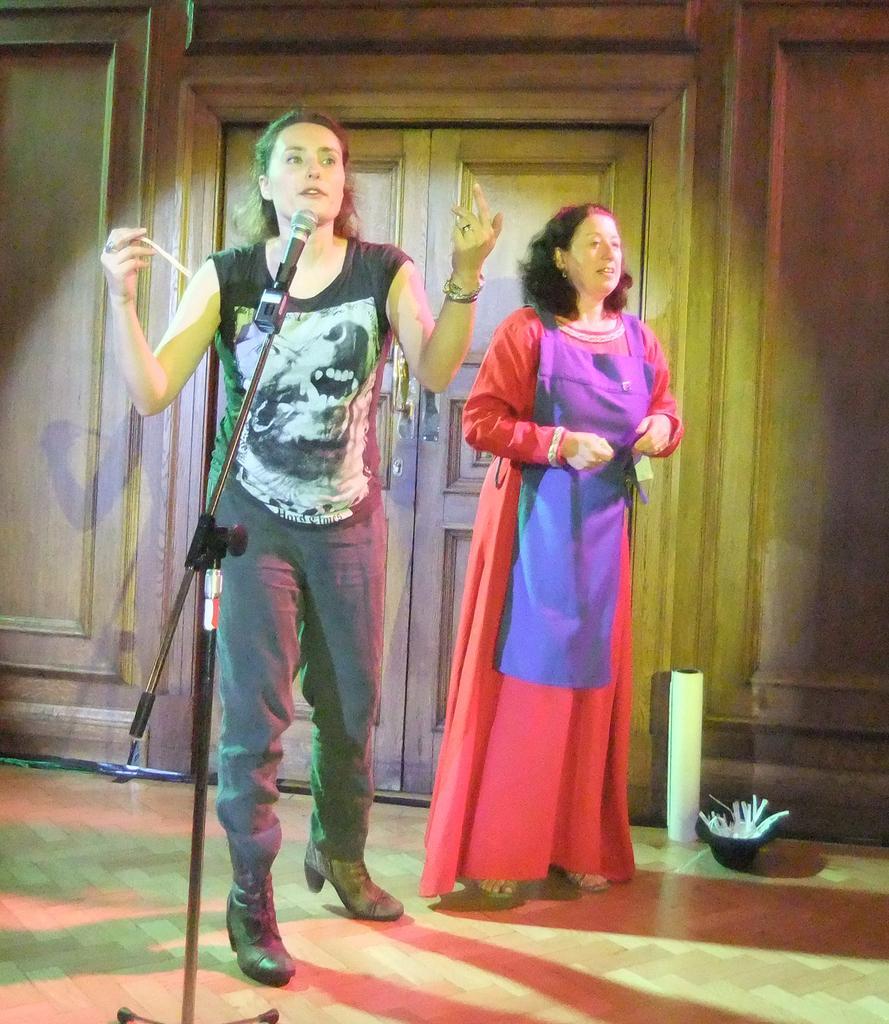Please provide a concise description of this image. In the picture I can see two women's, one is talking in front of microphone, another one is standing, behind we can see door to the wall. 